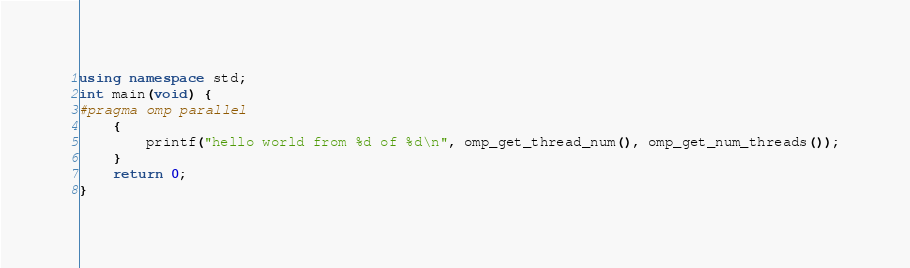<code> <loc_0><loc_0><loc_500><loc_500><_C++_>
using namespace std;
int main(void) {
#pragma omp parallel
	{
		printf("hello world from %d of %d\n", omp_get_thread_num(), omp_get_num_threads());
	}
	return 0;
}
</code> 